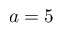<formula> <loc_0><loc_0><loc_500><loc_500>a = 5</formula> 